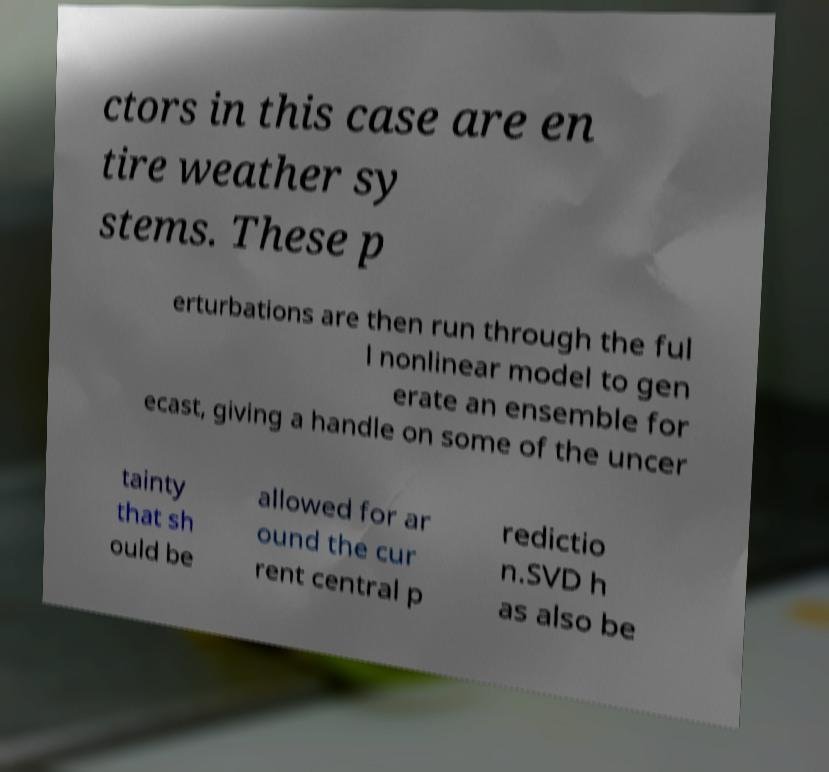What messages or text are displayed in this image? I need them in a readable, typed format. ctors in this case are en tire weather sy stems. These p erturbations are then run through the ful l nonlinear model to gen erate an ensemble for ecast, giving a handle on some of the uncer tainty that sh ould be allowed for ar ound the cur rent central p redictio n.SVD h as also be 